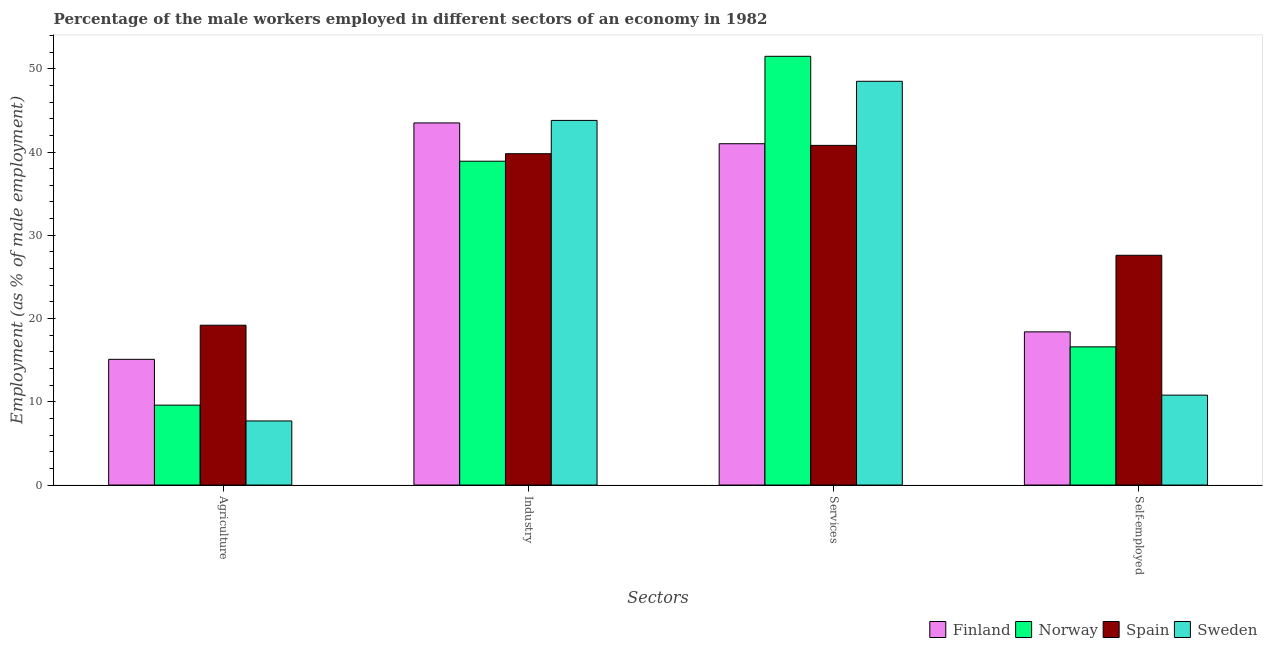Are the number of bars per tick equal to the number of legend labels?
Make the answer very short. Yes. Are the number of bars on each tick of the X-axis equal?
Ensure brevity in your answer.  Yes. How many bars are there on the 3rd tick from the left?
Your answer should be very brief. 4. What is the label of the 1st group of bars from the left?
Ensure brevity in your answer.  Agriculture. What is the percentage of male workers in industry in Spain?
Your answer should be very brief. 39.8. Across all countries, what is the maximum percentage of male workers in services?
Ensure brevity in your answer.  51.5. Across all countries, what is the minimum percentage of male workers in agriculture?
Keep it short and to the point. 7.7. What is the total percentage of male workers in agriculture in the graph?
Make the answer very short. 51.6. What is the difference between the percentage of male workers in services in Spain and that in Norway?
Make the answer very short. -10.7. What is the difference between the percentage of self employed male workers in Spain and the percentage of male workers in agriculture in Finland?
Keep it short and to the point. 12.5. What is the average percentage of male workers in services per country?
Make the answer very short. 45.45. What is the difference between the percentage of male workers in services and percentage of male workers in agriculture in Sweden?
Offer a very short reply. 40.8. In how many countries, is the percentage of male workers in services greater than 52 %?
Your answer should be compact. 0. What is the ratio of the percentage of self employed male workers in Norway to that in Spain?
Make the answer very short. 0.6. Is the difference between the percentage of male workers in agriculture in Norway and Finland greater than the difference between the percentage of male workers in industry in Norway and Finland?
Provide a succinct answer. No. What is the difference between the highest and the lowest percentage of self employed male workers?
Give a very brief answer. 16.8. In how many countries, is the percentage of male workers in agriculture greater than the average percentage of male workers in agriculture taken over all countries?
Keep it short and to the point. 2. What does the 3rd bar from the left in Self-employed represents?
Your answer should be compact. Spain. Is it the case that in every country, the sum of the percentage of male workers in agriculture and percentage of male workers in industry is greater than the percentage of male workers in services?
Make the answer very short. No. How many bars are there?
Make the answer very short. 16. What is the difference between two consecutive major ticks on the Y-axis?
Give a very brief answer. 10. Are the values on the major ticks of Y-axis written in scientific E-notation?
Make the answer very short. No. Where does the legend appear in the graph?
Provide a succinct answer. Bottom right. How many legend labels are there?
Give a very brief answer. 4. What is the title of the graph?
Your response must be concise. Percentage of the male workers employed in different sectors of an economy in 1982. Does "Belgium" appear as one of the legend labels in the graph?
Offer a terse response. No. What is the label or title of the X-axis?
Offer a terse response. Sectors. What is the label or title of the Y-axis?
Provide a succinct answer. Employment (as % of male employment). What is the Employment (as % of male employment) in Finland in Agriculture?
Offer a very short reply. 15.1. What is the Employment (as % of male employment) of Norway in Agriculture?
Your response must be concise. 9.6. What is the Employment (as % of male employment) in Spain in Agriculture?
Keep it short and to the point. 19.2. What is the Employment (as % of male employment) of Sweden in Agriculture?
Your answer should be very brief. 7.7. What is the Employment (as % of male employment) of Finland in Industry?
Provide a short and direct response. 43.5. What is the Employment (as % of male employment) of Norway in Industry?
Make the answer very short. 38.9. What is the Employment (as % of male employment) of Spain in Industry?
Your response must be concise. 39.8. What is the Employment (as % of male employment) of Sweden in Industry?
Your response must be concise. 43.8. What is the Employment (as % of male employment) in Finland in Services?
Your answer should be very brief. 41. What is the Employment (as % of male employment) in Norway in Services?
Give a very brief answer. 51.5. What is the Employment (as % of male employment) of Spain in Services?
Offer a terse response. 40.8. What is the Employment (as % of male employment) of Sweden in Services?
Offer a terse response. 48.5. What is the Employment (as % of male employment) in Finland in Self-employed?
Provide a succinct answer. 18.4. What is the Employment (as % of male employment) in Norway in Self-employed?
Your response must be concise. 16.6. What is the Employment (as % of male employment) of Spain in Self-employed?
Ensure brevity in your answer.  27.6. What is the Employment (as % of male employment) of Sweden in Self-employed?
Give a very brief answer. 10.8. Across all Sectors, what is the maximum Employment (as % of male employment) in Finland?
Give a very brief answer. 43.5. Across all Sectors, what is the maximum Employment (as % of male employment) of Norway?
Make the answer very short. 51.5. Across all Sectors, what is the maximum Employment (as % of male employment) of Spain?
Your answer should be very brief. 40.8. Across all Sectors, what is the maximum Employment (as % of male employment) of Sweden?
Provide a short and direct response. 48.5. Across all Sectors, what is the minimum Employment (as % of male employment) of Finland?
Make the answer very short. 15.1. Across all Sectors, what is the minimum Employment (as % of male employment) of Norway?
Keep it short and to the point. 9.6. Across all Sectors, what is the minimum Employment (as % of male employment) of Spain?
Provide a succinct answer. 19.2. Across all Sectors, what is the minimum Employment (as % of male employment) in Sweden?
Offer a very short reply. 7.7. What is the total Employment (as % of male employment) of Finland in the graph?
Provide a succinct answer. 118. What is the total Employment (as % of male employment) of Norway in the graph?
Provide a short and direct response. 116.6. What is the total Employment (as % of male employment) in Spain in the graph?
Make the answer very short. 127.4. What is the total Employment (as % of male employment) of Sweden in the graph?
Provide a short and direct response. 110.8. What is the difference between the Employment (as % of male employment) in Finland in Agriculture and that in Industry?
Make the answer very short. -28.4. What is the difference between the Employment (as % of male employment) in Norway in Agriculture and that in Industry?
Your answer should be compact. -29.3. What is the difference between the Employment (as % of male employment) of Spain in Agriculture and that in Industry?
Keep it short and to the point. -20.6. What is the difference between the Employment (as % of male employment) of Sweden in Agriculture and that in Industry?
Your answer should be compact. -36.1. What is the difference between the Employment (as % of male employment) in Finland in Agriculture and that in Services?
Offer a terse response. -25.9. What is the difference between the Employment (as % of male employment) in Norway in Agriculture and that in Services?
Your answer should be compact. -41.9. What is the difference between the Employment (as % of male employment) in Spain in Agriculture and that in Services?
Your answer should be compact. -21.6. What is the difference between the Employment (as % of male employment) of Sweden in Agriculture and that in Services?
Your answer should be very brief. -40.8. What is the difference between the Employment (as % of male employment) of Finland in Agriculture and that in Self-employed?
Your answer should be compact. -3.3. What is the difference between the Employment (as % of male employment) in Norway in Agriculture and that in Self-employed?
Your answer should be compact. -7. What is the difference between the Employment (as % of male employment) in Norway in Industry and that in Services?
Provide a succinct answer. -12.6. What is the difference between the Employment (as % of male employment) in Sweden in Industry and that in Services?
Provide a succinct answer. -4.7. What is the difference between the Employment (as % of male employment) in Finland in Industry and that in Self-employed?
Keep it short and to the point. 25.1. What is the difference between the Employment (as % of male employment) of Norway in Industry and that in Self-employed?
Provide a short and direct response. 22.3. What is the difference between the Employment (as % of male employment) in Spain in Industry and that in Self-employed?
Offer a terse response. 12.2. What is the difference between the Employment (as % of male employment) in Finland in Services and that in Self-employed?
Offer a terse response. 22.6. What is the difference between the Employment (as % of male employment) in Norway in Services and that in Self-employed?
Give a very brief answer. 34.9. What is the difference between the Employment (as % of male employment) of Spain in Services and that in Self-employed?
Keep it short and to the point. 13.2. What is the difference between the Employment (as % of male employment) in Sweden in Services and that in Self-employed?
Give a very brief answer. 37.7. What is the difference between the Employment (as % of male employment) in Finland in Agriculture and the Employment (as % of male employment) in Norway in Industry?
Ensure brevity in your answer.  -23.8. What is the difference between the Employment (as % of male employment) in Finland in Agriculture and the Employment (as % of male employment) in Spain in Industry?
Provide a succinct answer. -24.7. What is the difference between the Employment (as % of male employment) of Finland in Agriculture and the Employment (as % of male employment) of Sweden in Industry?
Provide a succinct answer. -28.7. What is the difference between the Employment (as % of male employment) in Norway in Agriculture and the Employment (as % of male employment) in Spain in Industry?
Give a very brief answer. -30.2. What is the difference between the Employment (as % of male employment) in Norway in Agriculture and the Employment (as % of male employment) in Sweden in Industry?
Ensure brevity in your answer.  -34.2. What is the difference between the Employment (as % of male employment) in Spain in Agriculture and the Employment (as % of male employment) in Sweden in Industry?
Provide a short and direct response. -24.6. What is the difference between the Employment (as % of male employment) of Finland in Agriculture and the Employment (as % of male employment) of Norway in Services?
Your response must be concise. -36.4. What is the difference between the Employment (as % of male employment) in Finland in Agriculture and the Employment (as % of male employment) in Spain in Services?
Your answer should be very brief. -25.7. What is the difference between the Employment (as % of male employment) in Finland in Agriculture and the Employment (as % of male employment) in Sweden in Services?
Make the answer very short. -33.4. What is the difference between the Employment (as % of male employment) in Norway in Agriculture and the Employment (as % of male employment) in Spain in Services?
Give a very brief answer. -31.2. What is the difference between the Employment (as % of male employment) in Norway in Agriculture and the Employment (as % of male employment) in Sweden in Services?
Provide a short and direct response. -38.9. What is the difference between the Employment (as % of male employment) of Spain in Agriculture and the Employment (as % of male employment) of Sweden in Services?
Make the answer very short. -29.3. What is the difference between the Employment (as % of male employment) in Finland in Agriculture and the Employment (as % of male employment) in Spain in Self-employed?
Your response must be concise. -12.5. What is the difference between the Employment (as % of male employment) in Norway in Agriculture and the Employment (as % of male employment) in Spain in Self-employed?
Provide a short and direct response. -18. What is the difference between the Employment (as % of male employment) in Norway in Agriculture and the Employment (as % of male employment) in Sweden in Self-employed?
Ensure brevity in your answer.  -1.2. What is the difference between the Employment (as % of male employment) of Finland in Industry and the Employment (as % of male employment) of Norway in Services?
Ensure brevity in your answer.  -8. What is the difference between the Employment (as % of male employment) of Spain in Industry and the Employment (as % of male employment) of Sweden in Services?
Give a very brief answer. -8.7. What is the difference between the Employment (as % of male employment) in Finland in Industry and the Employment (as % of male employment) in Norway in Self-employed?
Keep it short and to the point. 26.9. What is the difference between the Employment (as % of male employment) in Finland in Industry and the Employment (as % of male employment) in Sweden in Self-employed?
Offer a very short reply. 32.7. What is the difference between the Employment (as % of male employment) in Norway in Industry and the Employment (as % of male employment) in Sweden in Self-employed?
Make the answer very short. 28.1. What is the difference between the Employment (as % of male employment) of Spain in Industry and the Employment (as % of male employment) of Sweden in Self-employed?
Give a very brief answer. 29. What is the difference between the Employment (as % of male employment) of Finland in Services and the Employment (as % of male employment) of Norway in Self-employed?
Ensure brevity in your answer.  24.4. What is the difference between the Employment (as % of male employment) in Finland in Services and the Employment (as % of male employment) in Spain in Self-employed?
Make the answer very short. 13.4. What is the difference between the Employment (as % of male employment) of Finland in Services and the Employment (as % of male employment) of Sweden in Self-employed?
Provide a short and direct response. 30.2. What is the difference between the Employment (as % of male employment) in Norway in Services and the Employment (as % of male employment) in Spain in Self-employed?
Keep it short and to the point. 23.9. What is the difference between the Employment (as % of male employment) in Norway in Services and the Employment (as % of male employment) in Sweden in Self-employed?
Your response must be concise. 40.7. What is the difference between the Employment (as % of male employment) in Spain in Services and the Employment (as % of male employment) in Sweden in Self-employed?
Ensure brevity in your answer.  30. What is the average Employment (as % of male employment) of Finland per Sectors?
Make the answer very short. 29.5. What is the average Employment (as % of male employment) in Norway per Sectors?
Your answer should be very brief. 29.15. What is the average Employment (as % of male employment) of Spain per Sectors?
Offer a very short reply. 31.85. What is the average Employment (as % of male employment) of Sweden per Sectors?
Your answer should be compact. 27.7. What is the difference between the Employment (as % of male employment) in Finland and Employment (as % of male employment) in Sweden in Agriculture?
Keep it short and to the point. 7.4. What is the difference between the Employment (as % of male employment) in Norway and Employment (as % of male employment) in Spain in Agriculture?
Your answer should be compact. -9.6. What is the difference between the Employment (as % of male employment) in Norway and Employment (as % of male employment) in Sweden in Agriculture?
Your response must be concise. 1.9. What is the difference between the Employment (as % of male employment) in Spain and Employment (as % of male employment) in Sweden in Agriculture?
Your answer should be very brief. 11.5. What is the difference between the Employment (as % of male employment) of Finland and Employment (as % of male employment) of Spain in Industry?
Offer a very short reply. 3.7. What is the difference between the Employment (as % of male employment) of Norway and Employment (as % of male employment) of Sweden in Industry?
Offer a very short reply. -4.9. What is the difference between the Employment (as % of male employment) in Finland and Employment (as % of male employment) in Norway in Services?
Provide a succinct answer. -10.5. What is the difference between the Employment (as % of male employment) in Finland and Employment (as % of male employment) in Sweden in Services?
Make the answer very short. -7.5. What is the difference between the Employment (as % of male employment) of Norway and Employment (as % of male employment) of Spain in Services?
Ensure brevity in your answer.  10.7. What is the difference between the Employment (as % of male employment) of Finland and Employment (as % of male employment) of Sweden in Self-employed?
Your response must be concise. 7.6. What is the difference between the Employment (as % of male employment) in Norway and Employment (as % of male employment) in Sweden in Self-employed?
Make the answer very short. 5.8. What is the difference between the Employment (as % of male employment) of Spain and Employment (as % of male employment) of Sweden in Self-employed?
Your response must be concise. 16.8. What is the ratio of the Employment (as % of male employment) of Finland in Agriculture to that in Industry?
Provide a succinct answer. 0.35. What is the ratio of the Employment (as % of male employment) of Norway in Agriculture to that in Industry?
Give a very brief answer. 0.25. What is the ratio of the Employment (as % of male employment) of Spain in Agriculture to that in Industry?
Keep it short and to the point. 0.48. What is the ratio of the Employment (as % of male employment) of Sweden in Agriculture to that in Industry?
Make the answer very short. 0.18. What is the ratio of the Employment (as % of male employment) in Finland in Agriculture to that in Services?
Give a very brief answer. 0.37. What is the ratio of the Employment (as % of male employment) of Norway in Agriculture to that in Services?
Your answer should be compact. 0.19. What is the ratio of the Employment (as % of male employment) of Spain in Agriculture to that in Services?
Your answer should be very brief. 0.47. What is the ratio of the Employment (as % of male employment) of Sweden in Agriculture to that in Services?
Make the answer very short. 0.16. What is the ratio of the Employment (as % of male employment) in Finland in Agriculture to that in Self-employed?
Offer a very short reply. 0.82. What is the ratio of the Employment (as % of male employment) of Norway in Agriculture to that in Self-employed?
Provide a succinct answer. 0.58. What is the ratio of the Employment (as % of male employment) in Spain in Agriculture to that in Self-employed?
Your answer should be very brief. 0.7. What is the ratio of the Employment (as % of male employment) of Sweden in Agriculture to that in Self-employed?
Provide a short and direct response. 0.71. What is the ratio of the Employment (as % of male employment) in Finland in Industry to that in Services?
Ensure brevity in your answer.  1.06. What is the ratio of the Employment (as % of male employment) of Norway in Industry to that in Services?
Your answer should be very brief. 0.76. What is the ratio of the Employment (as % of male employment) of Spain in Industry to that in Services?
Give a very brief answer. 0.98. What is the ratio of the Employment (as % of male employment) of Sweden in Industry to that in Services?
Your response must be concise. 0.9. What is the ratio of the Employment (as % of male employment) in Finland in Industry to that in Self-employed?
Provide a succinct answer. 2.36. What is the ratio of the Employment (as % of male employment) of Norway in Industry to that in Self-employed?
Give a very brief answer. 2.34. What is the ratio of the Employment (as % of male employment) in Spain in Industry to that in Self-employed?
Your answer should be compact. 1.44. What is the ratio of the Employment (as % of male employment) in Sweden in Industry to that in Self-employed?
Ensure brevity in your answer.  4.06. What is the ratio of the Employment (as % of male employment) of Finland in Services to that in Self-employed?
Keep it short and to the point. 2.23. What is the ratio of the Employment (as % of male employment) in Norway in Services to that in Self-employed?
Offer a terse response. 3.1. What is the ratio of the Employment (as % of male employment) of Spain in Services to that in Self-employed?
Offer a terse response. 1.48. What is the ratio of the Employment (as % of male employment) in Sweden in Services to that in Self-employed?
Keep it short and to the point. 4.49. What is the difference between the highest and the second highest Employment (as % of male employment) in Norway?
Your response must be concise. 12.6. What is the difference between the highest and the second highest Employment (as % of male employment) of Spain?
Your response must be concise. 1. What is the difference between the highest and the second highest Employment (as % of male employment) in Sweden?
Make the answer very short. 4.7. What is the difference between the highest and the lowest Employment (as % of male employment) in Finland?
Provide a short and direct response. 28.4. What is the difference between the highest and the lowest Employment (as % of male employment) of Norway?
Your answer should be very brief. 41.9. What is the difference between the highest and the lowest Employment (as % of male employment) of Spain?
Your response must be concise. 21.6. What is the difference between the highest and the lowest Employment (as % of male employment) in Sweden?
Provide a short and direct response. 40.8. 